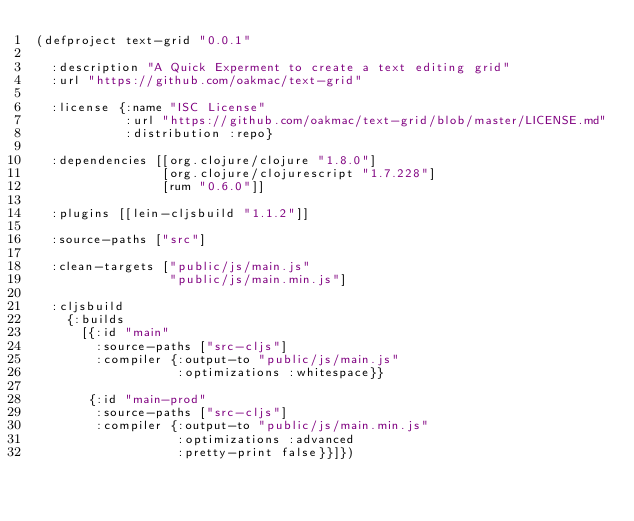<code> <loc_0><loc_0><loc_500><loc_500><_Clojure_>(defproject text-grid "0.0.1"

  :description "A Quick Experment to create a text editing grid"
  :url "https://github.com/oakmac/text-grid"

  :license {:name "ISC License"
            :url "https://github.com/oakmac/text-grid/blob/master/LICENSE.md"
            :distribution :repo}

  :dependencies [[org.clojure/clojure "1.8.0"]
                 [org.clojure/clojurescript "1.7.228"]
                 [rum "0.6.0"]]

  :plugins [[lein-cljsbuild "1.1.2"]]

  :source-paths ["src"]

  :clean-targets ["public/js/main.js"
                  "public/js/main.min.js"]

  :cljsbuild
    {:builds
      [{:id "main"
        :source-paths ["src-cljs"]
        :compiler {:output-to "public/js/main.js"
                   :optimizations :whitespace}}

       {:id "main-prod"
        :source-paths ["src-cljs"]
        :compiler {:output-to "public/js/main.min.js"
                   :optimizations :advanced
                   :pretty-print false}}]})
</code> 